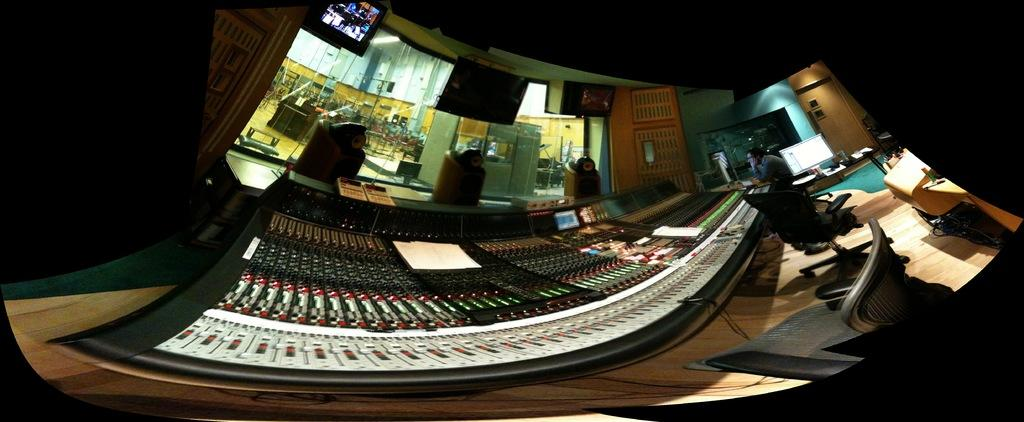What is the main subject in the image? There is a person in the image. What can be seen on the floor in the image? There are chairs on the floor in the image. What type of electronic devices are visible in the image? There are screens visible in the image. What is the background of the image made of? There is a wall in the image. What other objects can be seen in the image besides the person and chairs? There are other objects present in the image. What type of vegetable is being used to create a horn in the image? There is no vegetable or horn present in the image. 